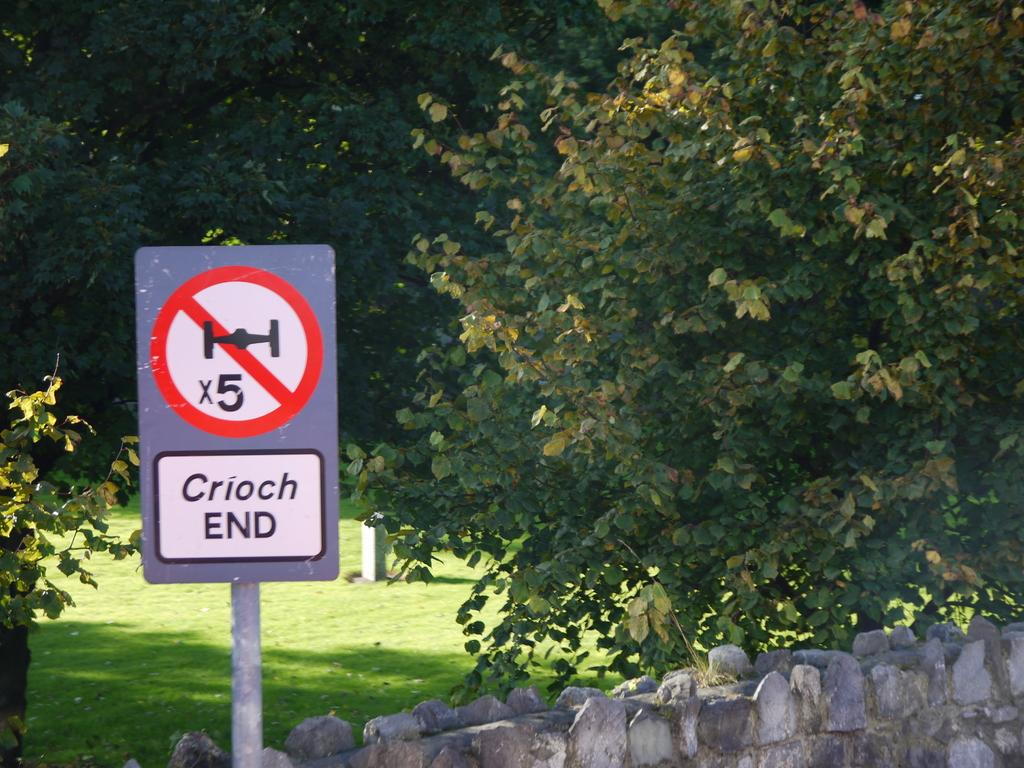<image>
Write a terse but informative summary of the picture. A silver and white warning says reads "Crioch END." 